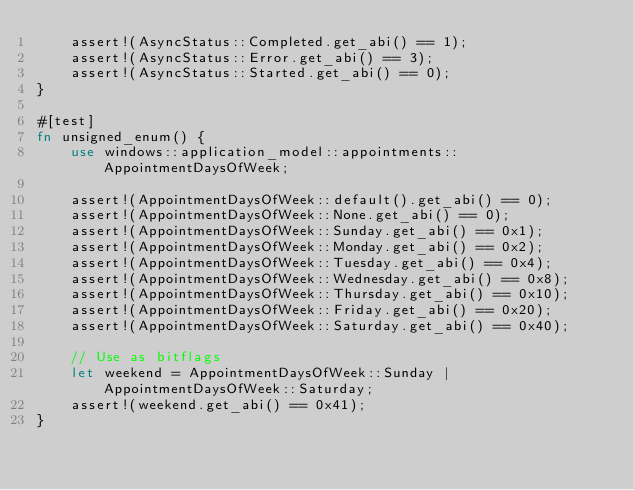Convert code to text. <code><loc_0><loc_0><loc_500><loc_500><_Rust_>    assert!(AsyncStatus::Completed.get_abi() == 1);
    assert!(AsyncStatus::Error.get_abi() == 3);
    assert!(AsyncStatus::Started.get_abi() == 0);
}

#[test]
fn unsigned_enum() {
    use windows::application_model::appointments::AppointmentDaysOfWeek;

    assert!(AppointmentDaysOfWeek::default().get_abi() == 0);
    assert!(AppointmentDaysOfWeek::None.get_abi() == 0);
    assert!(AppointmentDaysOfWeek::Sunday.get_abi() == 0x1);
    assert!(AppointmentDaysOfWeek::Monday.get_abi() == 0x2);
    assert!(AppointmentDaysOfWeek::Tuesday.get_abi() == 0x4);
    assert!(AppointmentDaysOfWeek::Wednesday.get_abi() == 0x8);
    assert!(AppointmentDaysOfWeek::Thursday.get_abi() == 0x10);
    assert!(AppointmentDaysOfWeek::Friday.get_abi() == 0x20);
    assert!(AppointmentDaysOfWeek::Saturday.get_abi() == 0x40);

    // Use as bitflags
    let weekend = AppointmentDaysOfWeek::Sunday | AppointmentDaysOfWeek::Saturday;
    assert!(weekend.get_abi() == 0x41);
}
</code> 